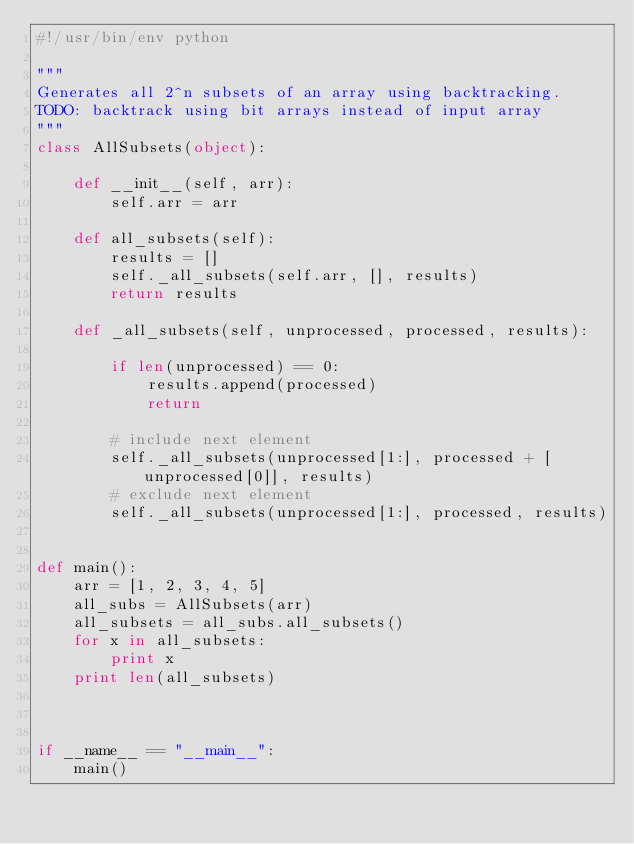Convert code to text. <code><loc_0><loc_0><loc_500><loc_500><_Python_>#!/usr/bin/env python

"""
Generates all 2^n subsets of an array using backtracking.
TODO: backtrack using bit arrays instead of input array
"""
class AllSubsets(object):

    def __init__(self, arr):
        self.arr = arr

    def all_subsets(self):
        results = []
        self._all_subsets(self.arr, [], results)
        return results

    def _all_subsets(self, unprocessed, processed, results):

        if len(unprocessed) == 0:
            results.append(processed)
            return

        # include next element
        self._all_subsets(unprocessed[1:], processed + [unprocessed[0]], results)
        # exclude next element
        self._all_subsets(unprocessed[1:], processed, results)


def main():
    arr = [1, 2, 3, 4, 5]
    all_subs = AllSubsets(arr)
    all_subsets = all_subs.all_subsets()
    for x in all_subsets:
        print x
    print len(all_subsets)



if __name__ == "__main__":
    main()</code> 